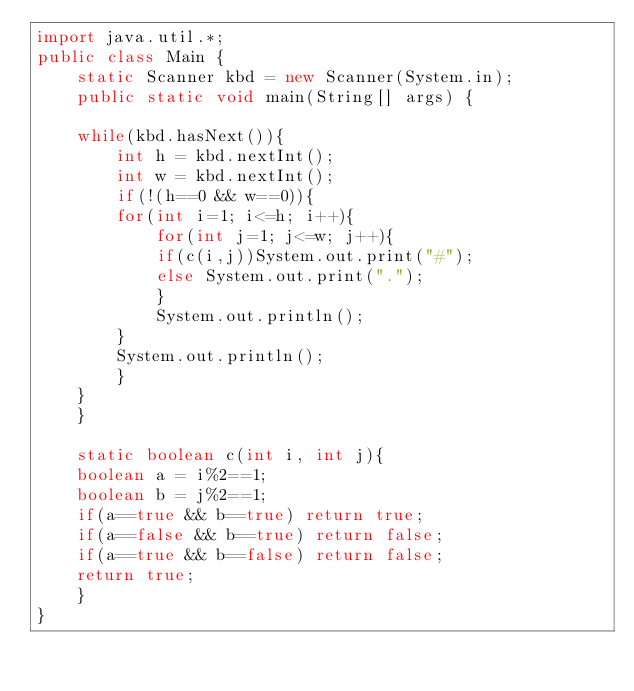Convert code to text. <code><loc_0><loc_0><loc_500><loc_500><_Java_>import java.util.*;
public class Main {
    static Scanner kbd = new Scanner(System.in);
    public static void main(String[] args) {

	while(kbd.hasNext()){
	    int h = kbd.nextInt();
	    int w = kbd.nextInt();
	    if(!(h==0 && w==0)){
		for(int i=1; i<=h; i++){
		    for(int j=1; j<=w; j++){
			if(c(i,j))System.out.print("#");
			else System.out.print(".");
		    }
		    System.out.println();
		}
		System.out.println();
	    }
	}
    }

    static boolean c(int i, int j){
	boolean a = i%2==1;
	boolean b = j%2==1;
	if(a==true && b==true) return true;
	if(a==false && b==true) return false;
	if(a==true && b==false) return false;
	return true;
    }
}</code> 